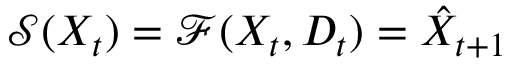<formula> <loc_0><loc_0><loc_500><loc_500>\mathcal { S } ( X _ { t } ) = \mathcal { F } ( X _ { t } , D _ { t } ) = \hat { X } _ { t + 1 }</formula> 